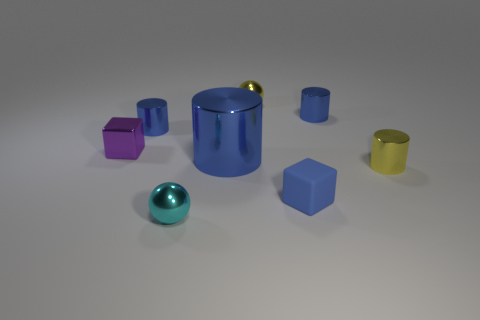There is a block in front of the purple cube; is its size the same as the big blue cylinder?
Keep it short and to the point. No. Are there fewer tiny balls right of the tiny yellow shiny sphere than shiny cylinders that are on the left side of the small cyan shiny ball?
Provide a short and direct response. Yes. Is the color of the rubber cube the same as the large shiny cylinder?
Keep it short and to the point. Yes. Is the number of tiny yellow objects to the left of the tiny yellow shiny sphere less than the number of blue cylinders?
Keep it short and to the point. Yes. There is another large object that is the same color as the matte thing; what is it made of?
Offer a terse response. Metal. Are the tiny yellow sphere and the blue block made of the same material?
Your answer should be very brief. No. What number of purple cubes are the same material as the large cylinder?
Your answer should be very brief. 1. What color is the other sphere that is the same material as the cyan sphere?
Provide a succinct answer. Yellow. There is a large object; what shape is it?
Your response must be concise. Cylinder. There is a tiny cylinder in front of the tiny metallic block; what is its material?
Provide a succinct answer. Metal. 